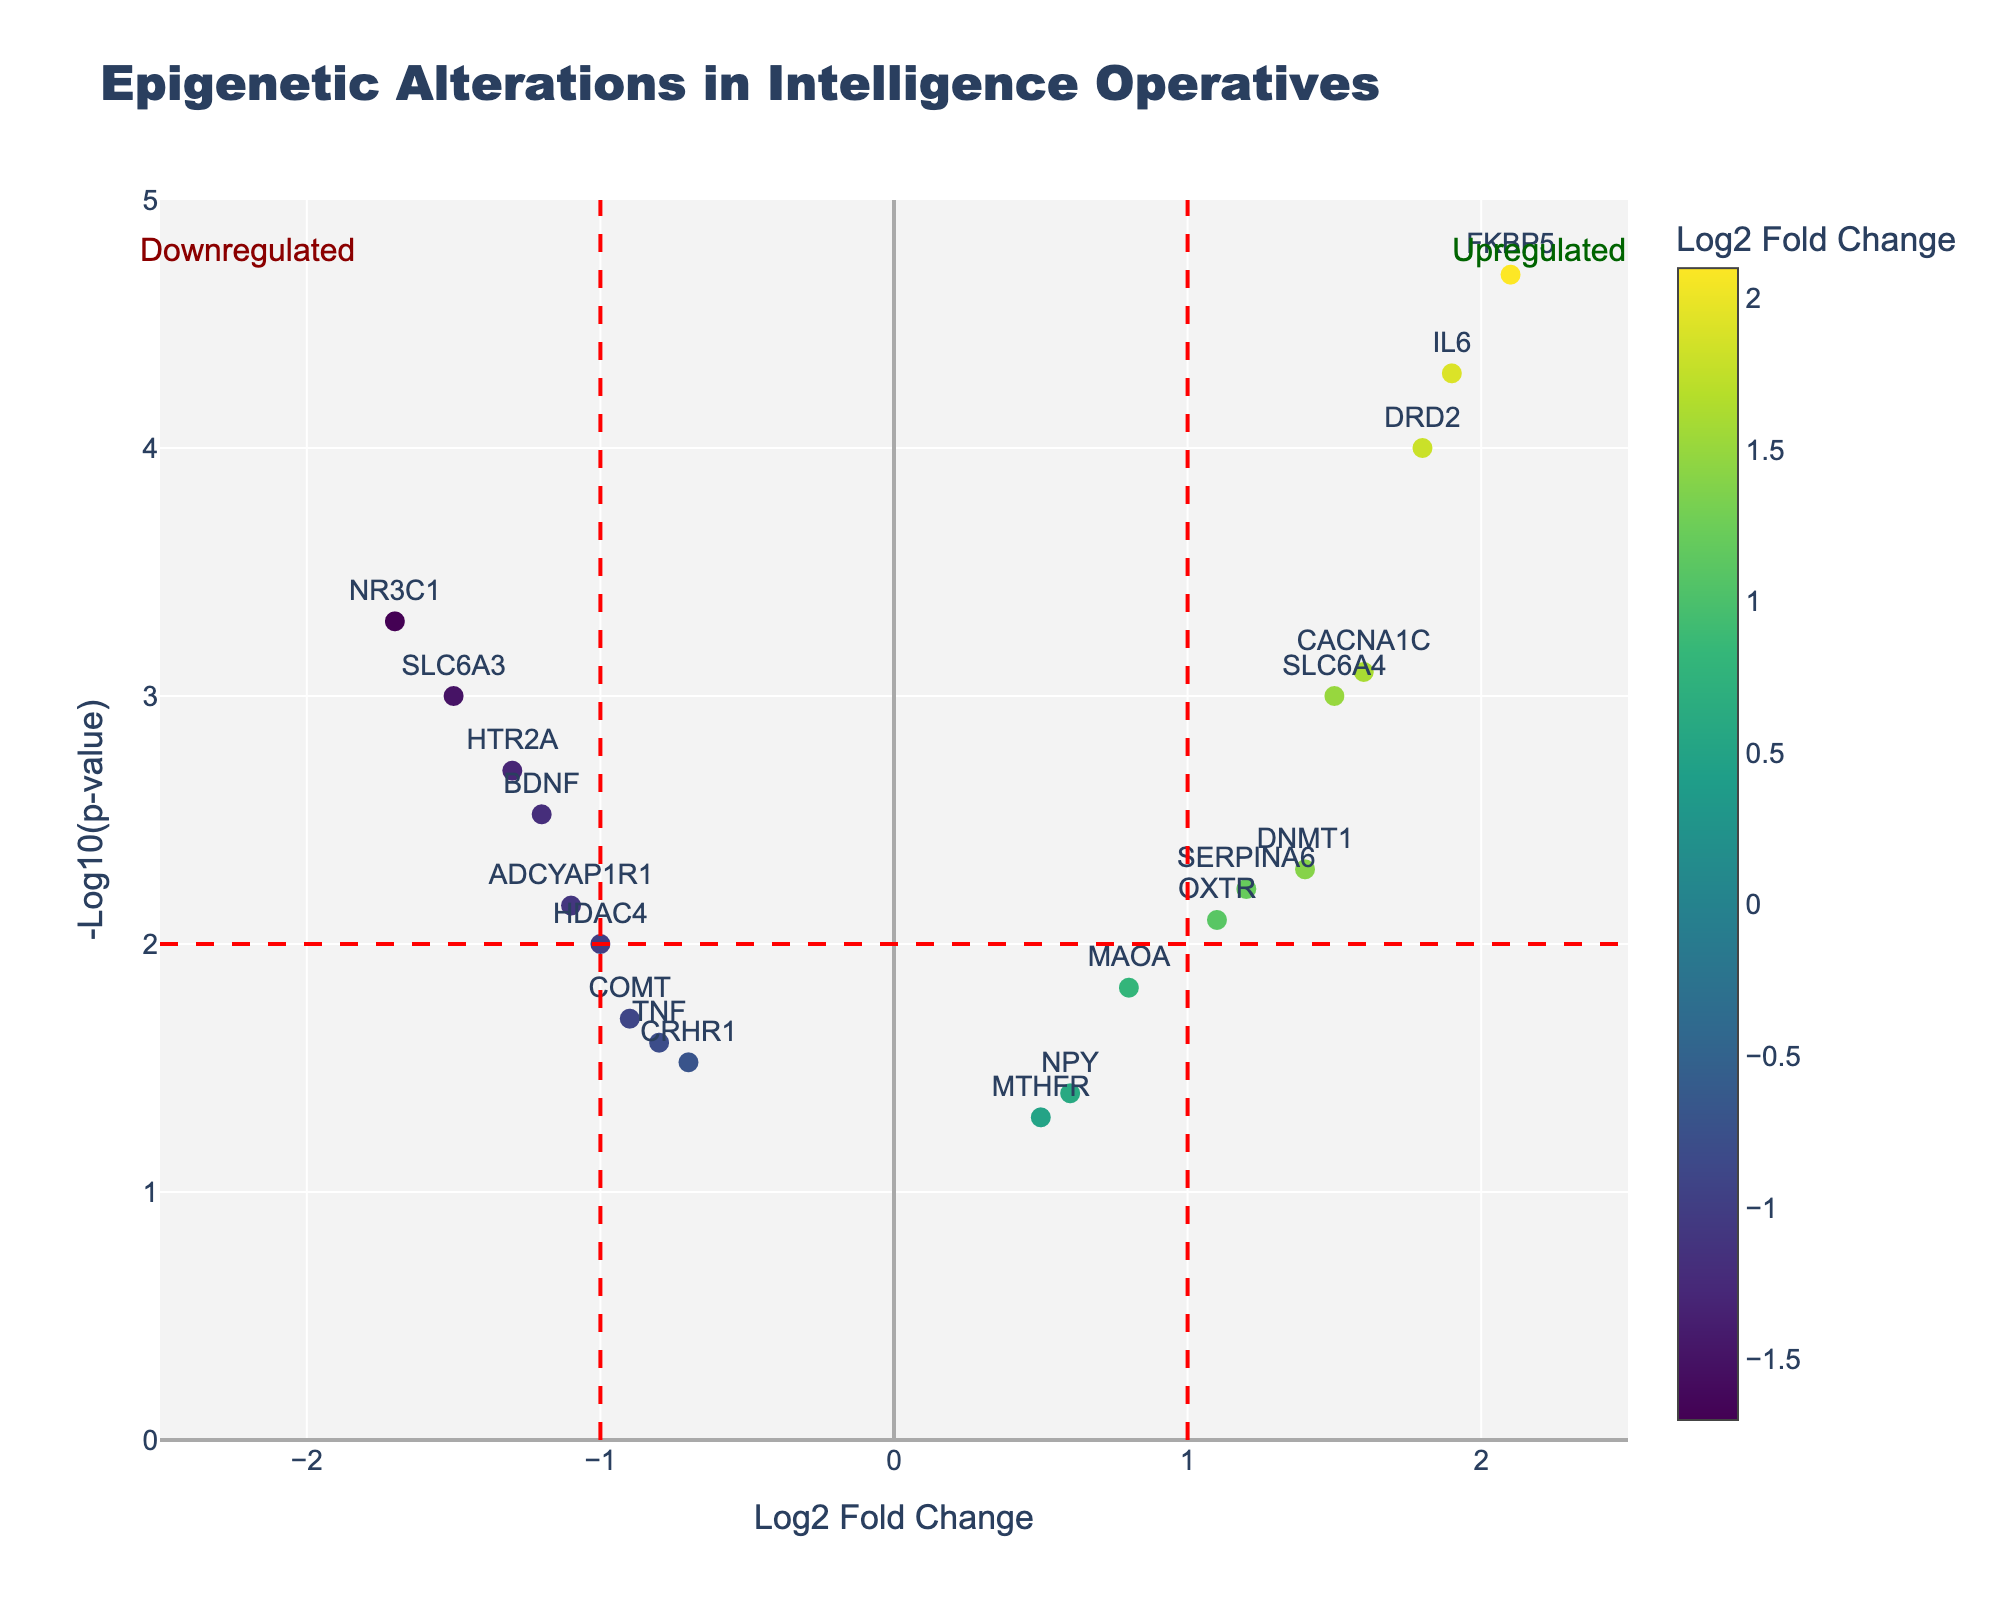What is the title of the figure? The title of the figure appears at the top and reads "Epigenetic Alterations in Intelligence Operatives".
Answer: Epigenetic Alterations in Intelligence Operatives How many genes showed upregulation (Log2FC > 0) with statistically significant p-values (p < 0.05)? To find upregulated genes with statistically significant p-values, we look for points to the right of the zero on the x-axis (Log2FC > 0) and above the horizontal line at -log10(p-value) = 2 (p < 0.05). Count each gene that meets these criteria.
Answer: 8 Which gene has the highest -log10(p-value)? The y-axis represents -log10(p-value). The gene plotted highest on the y-axis has the highest -log10(p-value). This means it has the smallest p-value.
Answer: FKBP5 What is the log2FoldChange (Log2FC) value for gene DRD2? The Log2FC value can be found directly by locating the point labeled "DRD2" on the x-axis. It is around 1.8.
Answer: 1.8 Which gene showed the strongest downregulation? The strongest downregulation corresponds to the most negative Log2FC value, which is found all the way to the left on the x-axis.
Answer: NR3C1 How many genes have p-values lower than 0.01? Genes with -log10(p-value) values greater than 2 correspond to p-values smaller than 0.01. Count all points above the horizontal line at -log10(p-value) = 2.
Answer: 10 Compare the Log2FC values of genes BDNF and IL6. Which one is more upregulated? The Log2FC value represents the fold-change on the x-axis. BDNF has a Log2FC of -1.2, and IL6 has a Log2FC of 1.9. Since 1.9 is greater than -1.2, IL6 is more upregulated.
Answer: IL6 What does a Log2FC value of 0 indicate in the context of this plot? A Log2FC value of 0 means no change in gene expression levels between conditions. Points with Log2FC = 0 lie on the y-axis.
Answer: No change How many genes have -log10(p-value) values higher than 3? Genes with -log10(p-value) higher than 3 are located above the horizontal line at y = 3. Count all such points.
Answer: 4 